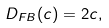<formula> <loc_0><loc_0><loc_500><loc_500>D _ { F B } ( c ) = 2 c ,</formula> 